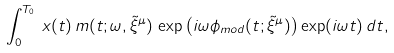<formula> <loc_0><loc_0><loc_500><loc_500>\int ^ { T _ { 0 } } _ { 0 } \, x ( t ) \, m ( t ; \omega , \tilde { \xi } ^ { \mu } ) \, \exp \left ( i \omega \phi _ { m o d } ( t ; \tilde { \xi } ^ { \mu } ) \right ) \exp ( i \omega t ) \, d t ,</formula> 